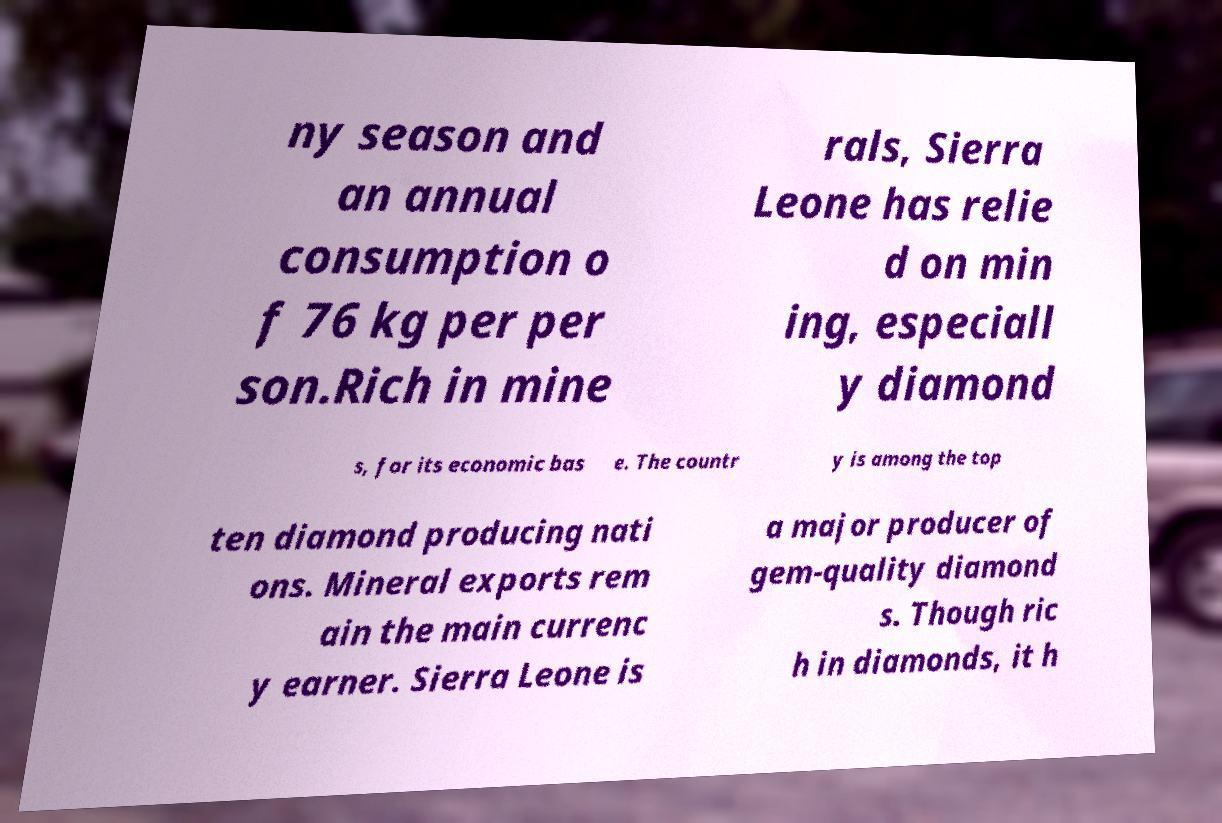There's text embedded in this image that I need extracted. Can you transcribe it verbatim? ny season and an annual consumption o f 76 kg per per son.Rich in mine rals, Sierra Leone has relie d on min ing, especiall y diamond s, for its economic bas e. The countr y is among the top ten diamond producing nati ons. Mineral exports rem ain the main currenc y earner. Sierra Leone is a major producer of gem-quality diamond s. Though ric h in diamonds, it h 